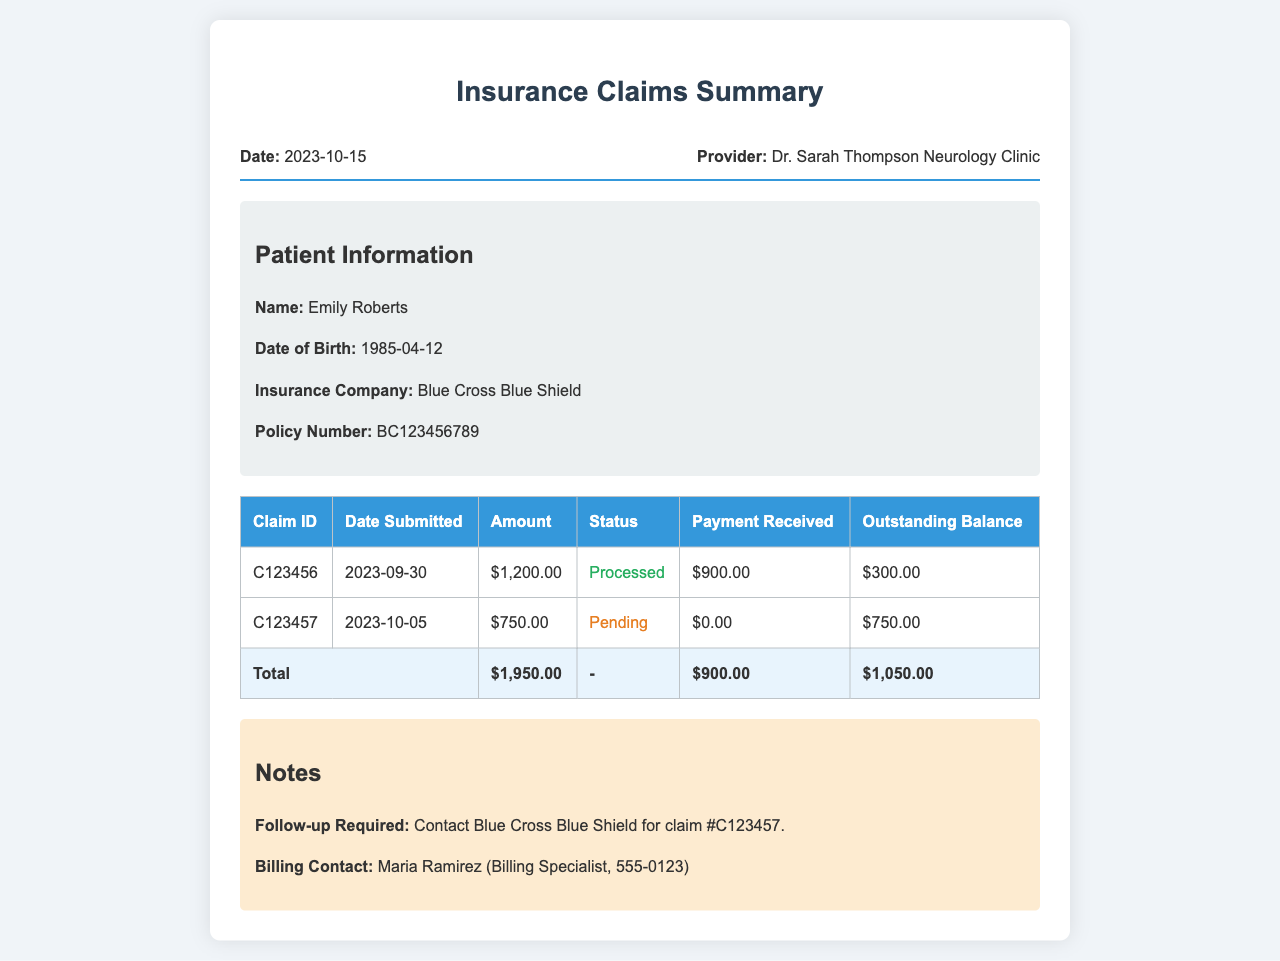What is the date of the document? The date of the document is listed in the header section, which shows 2023-10-15.
Answer: 2023-10-15 Who is the patient? The patient's name is mentioned in the patient information section, stating Emily Roberts.
Answer: Emily Roberts What is the amount for Claim ID C123456? The amount for Claim ID C123456 is found in the table under the "Amount" column, which shows $1,200.00.
Answer: $1,200.00 What is the status of Claim ID C123457? The status of Claim ID C123457 is classified under the "Status" column, which indicates that it is Pending.
Answer: Pending What is the total outstanding balance? The total outstanding balance is calculated based on the last row of the table, which states $1,050.00.
Answer: $1,050.00 What is the billing contact's name? The billing contact's name is specified in the notes section, identifying Maria Ramirez.
Answer: Maria Ramirez What is the payment received for Claim ID C123456? The payment received for Claim ID C123456 is provided in the table, which shows $900.00.
Answer: $900.00 How many claims are processed? There is one claim marked as processed in the table, which is Claim ID C123456.
Answer: One What is the policy number? The policy number is included in the patient information section, which lists BC123456789.
Answer: BC123456789 